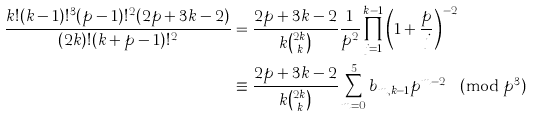Convert formula to latex. <formula><loc_0><loc_0><loc_500><loc_500>\frac { k ! ( k - 1 ) ! ^ { 3 } ( p - 1 ) ! ^ { 2 } ( 2 p + 3 k - 2 ) } { ( 2 k ) ! ( k + p - 1 ) ! ^ { 2 } } & = \frac { 2 p + 3 k - 2 } { k \binom { 2 k } { k } } \frac { 1 } { p ^ { 2 } } \prod _ { j = 1 } ^ { k - 1 } \left ( 1 + \frac { p } { j } \right ) ^ { - 2 } \\ & \equiv \frac { 2 p + 3 k - 2 } { k \binom { 2 k } { k } } \sum _ { m = 0 } ^ { 5 } b _ { m , k - 1 } p ^ { m - 2 } \pmod { p ^ { 3 } }</formula> 